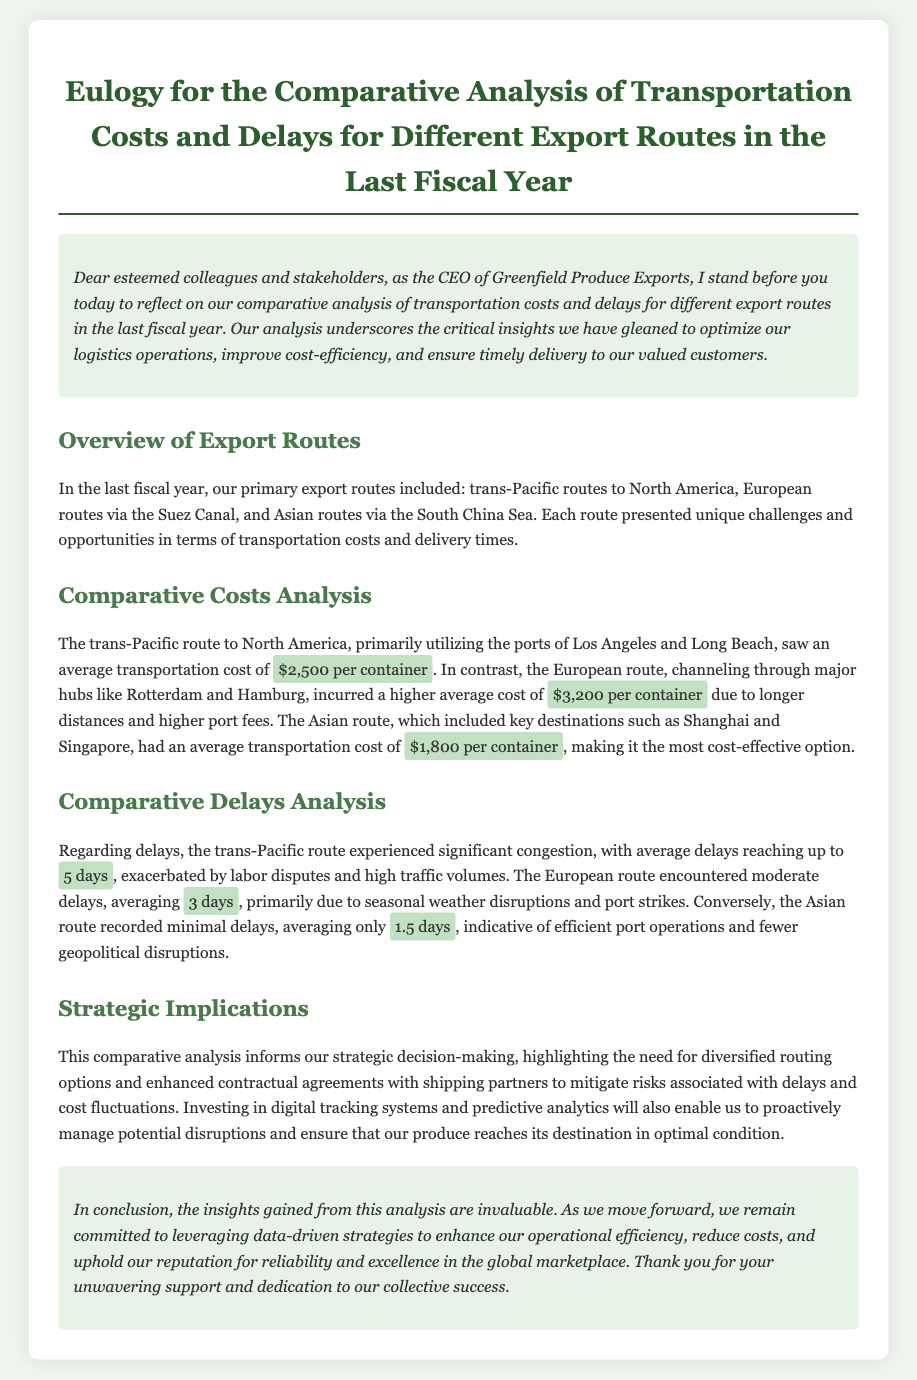What was the average transportation cost for the trans-Pacific route? The average transportation cost for the trans-Pacific route to North America is mentioned in the document as $2,500 per container.
Answer: $2,500 per container What was the average delay for the Asian route? The document specifies that the Asian route recorded minimal delays, averaging only 1.5 days.
Answer: 1.5 days Which export route had the highest average transportation cost? According to the analysis, the European route incurred the highest average cost at $3,200 per container.
Answer: $3,200 per container What are two factors contributing to the delays on the European route? The document lists seasonal weather disruptions and port strikes as contributing factors to delays on the European route.
Answer: Seasonal weather disruptions and port strikes What is a proposed strategy to mitigate risks associated with delays? The document indicates that investing in digital tracking systems and predictive analytics is a proposed strategy to manage potential disruptions.
Answer: Investing in digital tracking systems and predictive analytics What was the primary reason for significant congestion on the trans-Pacific route? Significant congestion on the trans-Pacific route was primarily caused by labor disputes and high traffic volumes, as stated in the document.
Answer: Labor disputes and high traffic volumes What is the tone of the conclusion in this eulogy? The tone of the conclusion is committed to leveraging data-driven strategies to enhance operational efficiency and uphold reliability.
Answer: Committed How many export routes were analyzed in the last fiscal year? The document mentions three primary export routes that were analyzed in the last fiscal year.
Answer: Three 